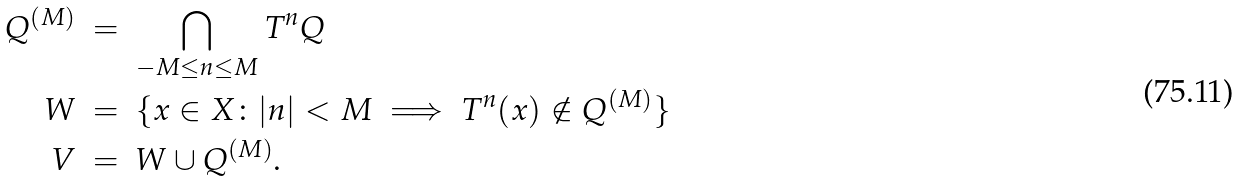Convert formula to latex. <formula><loc_0><loc_0><loc_500><loc_500>Q ^ { ( M ) } \ & = \ \bigcap _ { - M \leq n \leq M } T ^ { n } Q \\ W \ & = \ \{ x \in X \colon | n | < M \implies T ^ { n } ( x ) \notin Q ^ { ( M ) } \} \\ V \ & = \ W \cup Q ^ { ( M ) } .</formula> 